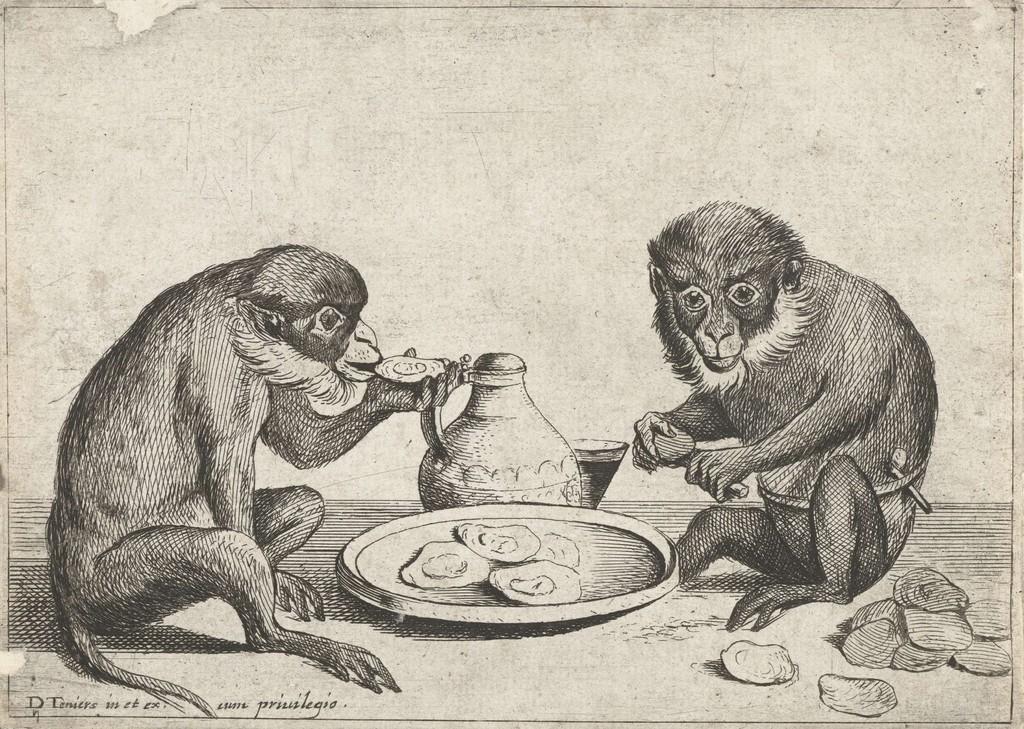Could you give a brief overview of what you see in this image? This picture shows painting and we see couple of monkeys and we see a plate and a jug. 